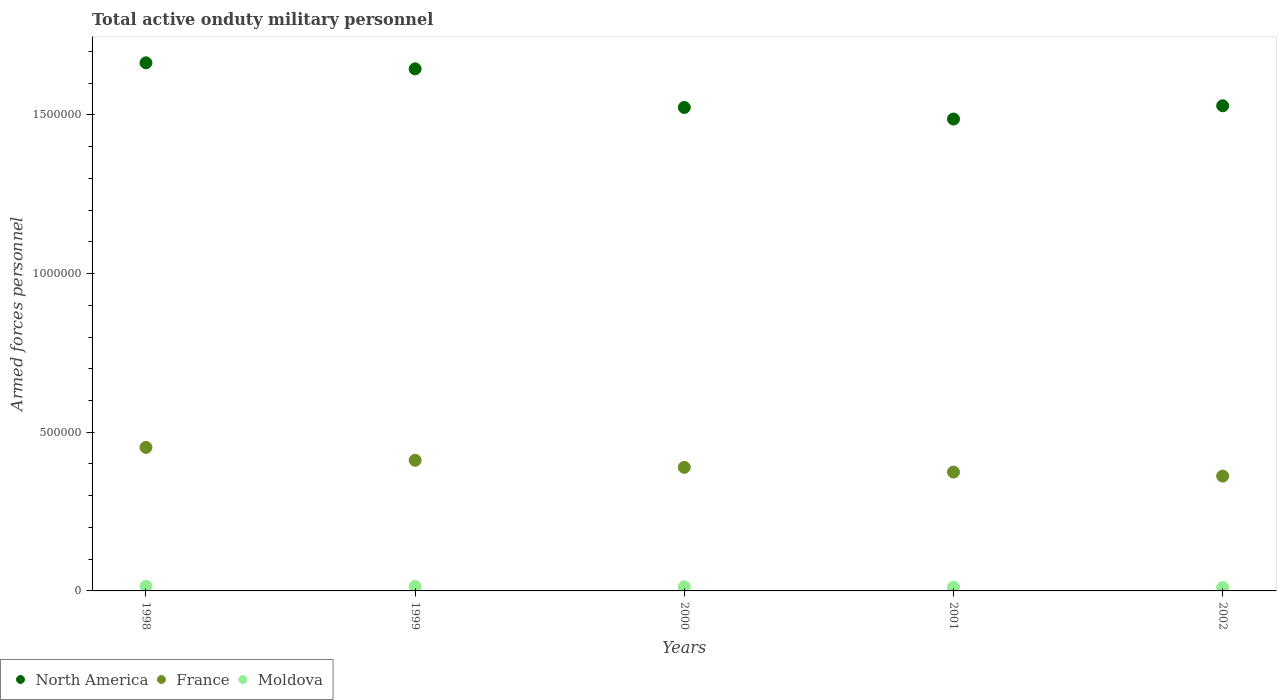What is the number of armed forces personnel in North America in 2002?
Offer a terse response. 1.53e+06. Across all years, what is the maximum number of armed forces personnel in Moldova?
Your answer should be compact. 1.44e+04. Across all years, what is the minimum number of armed forces personnel in France?
Give a very brief answer. 3.62e+05. In which year was the number of armed forces personnel in France maximum?
Your response must be concise. 1998. What is the total number of armed forces personnel in North America in the graph?
Offer a very short reply. 7.85e+06. What is the difference between the number of armed forces personnel in Moldova in 1999 and that in 2002?
Your response must be concise. 3450. What is the difference between the number of armed forces personnel in North America in 1999 and the number of armed forces personnel in Moldova in 2001?
Offer a terse response. 1.63e+06. What is the average number of armed forces personnel in Moldova per year?
Ensure brevity in your answer.  1.27e+04. In the year 1998, what is the difference between the number of armed forces personnel in North America and number of armed forces personnel in Moldova?
Give a very brief answer. 1.65e+06. In how many years, is the number of armed forces personnel in North America greater than 1500000?
Your response must be concise. 4. What is the ratio of the number of armed forces personnel in North America in 1998 to that in 1999?
Provide a succinct answer. 1.01. Is the number of armed forces personnel in North America in 1999 less than that in 2001?
Offer a very short reply. No. Is the difference between the number of armed forces personnel in North America in 1998 and 2001 greater than the difference between the number of armed forces personnel in Moldova in 1998 and 2001?
Provide a succinct answer. Yes. What is the difference between the highest and the second highest number of armed forces personnel in North America?
Provide a short and direct response. 1.90e+04. What is the difference between the highest and the lowest number of armed forces personnel in North America?
Your answer should be very brief. 1.77e+05. In how many years, is the number of armed forces personnel in Moldova greater than the average number of armed forces personnel in Moldova taken over all years?
Ensure brevity in your answer.  3. Does the number of armed forces personnel in Moldova monotonically increase over the years?
Make the answer very short. No. Is the number of armed forces personnel in Moldova strictly greater than the number of armed forces personnel in North America over the years?
Provide a succinct answer. No. How many years are there in the graph?
Make the answer very short. 5. What is the difference between two consecutive major ticks on the Y-axis?
Provide a short and direct response. 5.00e+05. Are the values on the major ticks of Y-axis written in scientific E-notation?
Offer a very short reply. No. Does the graph contain any zero values?
Your answer should be very brief. No. Where does the legend appear in the graph?
Offer a terse response. Bottom left. How are the legend labels stacked?
Your answer should be compact. Horizontal. What is the title of the graph?
Offer a terse response. Total active onduty military personnel. Does "Mozambique" appear as one of the legend labels in the graph?
Offer a terse response. No. What is the label or title of the X-axis?
Ensure brevity in your answer.  Years. What is the label or title of the Y-axis?
Offer a very short reply. Armed forces personnel. What is the Armed forces personnel in North America in 1998?
Provide a short and direct response. 1.66e+06. What is the Armed forces personnel in France in 1998?
Your answer should be compact. 4.52e+05. What is the Armed forces personnel of Moldova in 1998?
Offer a terse response. 1.44e+04. What is the Armed forces personnel of North America in 1999?
Your answer should be very brief. 1.64e+06. What is the Armed forces personnel in France in 1999?
Make the answer very short. 4.12e+05. What is the Armed forces personnel in Moldova in 1999?
Offer a very short reply. 1.40e+04. What is the Armed forces personnel in North America in 2000?
Offer a very short reply. 1.52e+06. What is the Armed forces personnel in France in 2000?
Ensure brevity in your answer.  3.89e+05. What is the Armed forces personnel in Moldova in 2000?
Your answer should be compact. 1.29e+04. What is the Armed forces personnel in North America in 2001?
Provide a succinct answer. 1.49e+06. What is the Armed forces personnel in France in 2001?
Your answer should be compact. 3.74e+05. What is the Armed forces personnel in Moldova in 2001?
Keep it short and to the point. 1.16e+04. What is the Armed forces personnel in North America in 2002?
Keep it short and to the point. 1.53e+06. What is the Armed forces personnel of France in 2002?
Provide a succinct answer. 3.62e+05. What is the Armed forces personnel in Moldova in 2002?
Make the answer very short. 1.06e+04. Across all years, what is the maximum Armed forces personnel in North America?
Make the answer very short. 1.66e+06. Across all years, what is the maximum Armed forces personnel in France?
Your answer should be compact. 4.52e+05. Across all years, what is the maximum Armed forces personnel of Moldova?
Give a very brief answer. 1.44e+04. Across all years, what is the minimum Armed forces personnel of North America?
Offer a very short reply. 1.49e+06. Across all years, what is the minimum Armed forces personnel in France?
Provide a short and direct response. 3.62e+05. Across all years, what is the minimum Armed forces personnel of Moldova?
Provide a succinct answer. 1.06e+04. What is the total Armed forces personnel of North America in the graph?
Provide a short and direct response. 7.85e+06. What is the total Armed forces personnel of France in the graph?
Provide a short and direct response. 1.99e+06. What is the total Armed forces personnel of Moldova in the graph?
Offer a terse response. 6.36e+04. What is the difference between the Armed forces personnel in North America in 1998 and that in 1999?
Keep it short and to the point. 1.90e+04. What is the difference between the Armed forces personnel of France in 1998 and that in 1999?
Your answer should be very brief. 4.06e+04. What is the difference between the Armed forces personnel in North America in 1998 and that in 2000?
Ensure brevity in your answer.  1.41e+05. What is the difference between the Armed forces personnel of France in 1998 and that in 2000?
Provide a succinct answer. 6.28e+04. What is the difference between the Armed forces personnel in Moldova in 1998 and that in 2000?
Your answer should be very brief. 1550. What is the difference between the Armed forces personnel in North America in 1998 and that in 2001?
Offer a very short reply. 1.77e+05. What is the difference between the Armed forces personnel in France in 1998 and that in 2001?
Offer a terse response. 7.78e+04. What is the difference between the Armed forces personnel of Moldova in 1998 and that in 2001?
Provide a succinct answer. 2850. What is the difference between the Armed forces personnel in North America in 1998 and that in 2002?
Ensure brevity in your answer.  1.35e+05. What is the difference between the Armed forces personnel in France in 1998 and that in 2002?
Make the answer very short. 9.04e+04. What is the difference between the Armed forces personnel of Moldova in 1998 and that in 2002?
Ensure brevity in your answer.  3850. What is the difference between the Armed forces personnel in North America in 1999 and that in 2000?
Your response must be concise. 1.22e+05. What is the difference between the Armed forces personnel of France in 1999 and that in 2000?
Keep it short and to the point. 2.22e+04. What is the difference between the Armed forces personnel of Moldova in 1999 and that in 2000?
Offer a very short reply. 1150. What is the difference between the Armed forces personnel of North America in 1999 and that in 2001?
Make the answer very short. 1.58e+05. What is the difference between the Armed forces personnel of France in 1999 and that in 2001?
Offer a very short reply. 3.72e+04. What is the difference between the Armed forces personnel in Moldova in 1999 and that in 2001?
Provide a short and direct response. 2450. What is the difference between the Armed forces personnel in North America in 1999 and that in 2002?
Your answer should be very brief. 1.16e+05. What is the difference between the Armed forces personnel in France in 1999 and that in 2002?
Give a very brief answer. 4.98e+04. What is the difference between the Armed forces personnel of Moldova in 1999 and that in 2002?
Offer a very short reply. 3450. What is the difference between the Armed forces personnel of North America in 2000 and that in 2001?
Provide a short and direct response. 3.65e+04. What is the difference between the Armed forces personnel of France in 2000 and that in 2001?
Provide a short and direct response. 1.50e+04. What is the difference between the Armed forces personnel of Moldova in 2000 and that in 2001?
Provide a short and direct response. 1300. What is the difference between the Armed forces personnel in North America in 2000 and that in 2002?
Give a very brief answer. -5300. What is the difference between the Armed forces personnel of France in 2000 and that in 2002?
Provide a succinct answer. 2.76e+04. What is the difference between the Armed forces personnel in Moldova in 2000 and that in 2002?
Offer a very short reply. 2300. What is the difference between the Armed forces personnel in North America in 2001 and that in 2002?
Ensure brevity in your answer.  -4.18e+04. What is the difference between the Armed forces personnel of France in 2001 and that in 2002?
Offer a terse response. 1.26e+04. What is the difference between the Armed forces personnel of Moldova in 2001 and that in 2002?
Make the answer very short. 1000. What is the difference between the Armed forces personnel of North America in 1998 and the Armed forces personnel of France in 1999?
Keep it short and to the point. 1.25e+06. What is the difference between the Armed forces personnel of North America in 1998 and the Armed forces personnel of Moldova in 1999?
Provide a short and direct response. 1.65e+06. What is the difference between the Armed forces personnel in France in 1998 and the Armed forces personnel in Moldova in 1999?
Keep it short and to the point. 4.38e+05. What is the difference between the Armed forces personnel of North America in 1998 and the Armed forces personnel of France in 2000?
Your answer should be compact. 1.27e+06. What is the difference between the Armed forces personnel of North America in 1998 and the Armed forces personnel of Moldova in 2000?
Provide a succinct answer. 1.65e+06. What is the difference between the Armed forces personnel in France in 1998 and the Armed forces personnel in Moldova in 2000?
Offer a very short reply. 4.39e+05. What is the difference between the Armed forces personnel of North America in 1998 and the Armed forces personnel of France in 2001?
Keep it short and to the point. 1.29e+06. What is the difference between the Armed forces personnel of North America in 1998 and the Armed forces personnel of Moldova in 2001?
Your answer should be very brief. 1.65e+06. What is the difference between the Armed forces personnel of France in 1998 and the Armed forces personnel of Moldova in 2001?
Keep it short and to the point. 4.41e+05. What is the difference between the Armed forces personnel in North America in 1998 and the Armed forces personnel in France in 2002?
Your answer should be compact. 1.30e+06. What is the difference between the Armed forces personnel in North America in 1998 and the Armed forces personnel in Moldova in 2002?
Give a very brief answer. 1.65e+06. What is the difference between the Armed forces personnel in France in 1998 and the Armed forces personnel in Moldova in 2002?
Your response must be concise. 4.42e+05. What is the difference between the Armed forces personnel in North America in 1999 and the Armed forces personnel in France in 2000?
Provide a succinct answer. 1.26e+06. What is the difference between the Armed forces personnel in North America in 1999 and the Armed forces personnel in Moldova in 2000?
Make the answer very short. 1.63e+06. What is the difference between the Armed forces personnel of France in 1999 and the Armed forces personnel of Moldova in 2000?
Offer a terse response. 3.99e+05. What is the difference between the Armed forces personnel in North America in 1999 and the Armed forces personnel in France in 2001?
Ensure brevity in your answer.  1.27e+06. What is the difference between the Armed forces personnel of North America in 1999 and the Armed forces personnel of Moldova in 2001?
Your answer should be compact. 1.63e+06. What is the difference between the Armed forces personnel in North America in 1999 and the Armed forces personnel in France in 2002?
Provide a short and direct response. 1.28e+06. What is the difference between the Armed forces personnel of North America in 1999 and the Armed forces personnel of Moldova in 2002?
Your answer should be very brief. 1.63e+06. What is the difference between the Armed forces personnel in France in 1999 and the Armed forces personnel in Moldova in 2002?
Your answer should be very brief. 4.01e+05. What is the difference between the Armed forces personnel of North America in 2000 and the Armed forces personnel of France in 2001?
Your response must be concise. 1.15e+06. What is the difference between the Armed forces personnel in North America in 2000 and the Armed forces personnel in Moldova in 2001?
Make the answer very short. 1.51e+06. What is the difference between the Armed forces personnel in France in 2000 and the Armed forces personnel in Moldova in 2001?
Ensure brevity in your answer.  3.78e+05. What is the difference between the Armed forces personnel of North America in 2000 and the Armed forces personnel of France in 2002?
Provide a short and direct response. 1.16e+06. What is the difference between the Armed forces personnel of North America in 2000 and the Armed forces personnel of Moldova in 2002?
Make the answer very short. 1.51e+06. What is the difference between the Armed forces personnel of France in 2000 and the Armed forces personnel of Moldova in 2002?
Keep it short and to the point. 3.79e+05. What is the difference between the Armed forces personnel in North America in 2001 and the Armed forces personnel in France in 2002?
Offer a terse response. 1.12e+06. What is the difference between the Armed forces personnel in North America in 2001 and the Armed forces personnel in Moldova in 2002?
Provide a short and direct response. 1.48e+06. What is the difference between the Armed forces personnel of France in 2001 and the Armed forces personnel of Moldova in 2002?
Your response must be concise. 3.64e+05. What is the average Armed forces personnel in North America per year?
Ensure brevity in your answer.  1.57e+06. What is the average Armed forces personnel in France per year?
Keep it short and to the point. 3.98e+05. What is the average Armed forces personnel of Moldova per year?
Make the answer very short. 1.27e+04. In the year 1998, what is the difference between the Armed forces personnel in North America and Armed forces personnel in France?
Make the answer very short. 1.21e+06. In the year 1998, what is the difference between the Armed forces personnel in North America and Armed forces personnel in Moldova?
Give a very brief answer. 1.65e+06. In the year 1998, what is the difference between the Armed forces personnel of France and Armed forces personnel of Moldova?
Provide a short and direct response. 4.38e+05. In the year 1999, what is the difference between the Armed forces personnel in North America and Armed forces personnel in France?
Offer a terse response. 1.23e+06. In the year 1999, what is the difference between the Armed forces personnel in North America and Armed forces personnel in Moldova?
Ensure brevity in your answer.  1.63e+06. In the year 1999, what is the difference between the Armed forces personnel of France and Armed forces personnel of Moldova?
Offer a terse response. 3.98e+05. In the year 2000, what is the difference between the Armed forces personnel in North America and Armed forces personnel in France?
Provide a succinct answer. 1.13e+06. In the year 2000, what is the difference between the Armed forces personnel of North America and Armed forces personnel of Moldova?
Offer a terse response. 1.51e+06. In the year 2000, what is the difference between the Armed forces personnel of France and Armed forces personnel of Moldova?
Your answer should be very brief. 3.76e+05. In the year 2001, what is the difference between the Armed forces personnel in North America and Armed forces personnel in France?
Give a very brief answer. 1.11e+06. In the year 2001, what is the difference between the Armed forces personnel of North America and Armed forces personnel of Moldova?
Ensure brevity in your answer.  1.48e+06. In the year 2001, what is the difference between the Armed forces personnel in France and Armed forces personnel in Moldova?
Your answer should be very brief. 3.63e+05. In the year 2002, what is the difference between the Armed forces personnel of North America and Armed forces personnel of France?
Provide a succinct answer. 1.17e+06. In the year 2002, what is the difference between the Armed forces personnel in North America and Armed forces personnel in Moldova?
Your answer should be very brief. 1.52e+06. In the year 2002, what is the difference between the Armed forces personnel in France and Armed forces personnel in Moldova?
Keep it short and to the point. 3.51e+05. What is the ratio of the Armed forces personnel of North America in 1998 to that in 1999?
Provide a short and direct response. 1.01. What is the ratio of the Armed forces personnel in France in 1998 to that in 1999?
Provide a succinct answer. 1.1. What is the ratio of the Armed forces personnel in Moldova in 1998 to that in 1999?
Make the answer very short. 1.03. What is the ratio of the Armed forces personnel of North America in 1998 to that in 2000?
Provide a short and direct response. 1.09. What is the ratio of the Armed forces personnel in France in 1998 to that in 2000?
Provide a succinct answer. 1.16. What is the ratio of the Armed forces personnel of Moldova in 1998 to that in 2000?
Offer a terse response. 1.12. What is the ratio of the Armed forces personnel in North America in 1998 to that in 2001?
Give a very brief answer. 1.12. What is the ratio of the Armed forces personnel of France in 1998 to that in 2001?
Ensure brevity in your answer.  1.21. What is the ratio of the Armed forces personnel of Moldova in 1998 to that in 2001?
Ensure brevity in your answer.  1.25. What is the ratio of the Armed forces personnel in North America in 1998 to that in 2002?
Provide a succinct answer. 1.09. What is the ratio of the Armed forces personnel of France in 1998 to that in 2002?
Keep it short and to the point. 1.25. What is the ratio of the Armed forces personnel of Moldova in 1998 to that in 2002?
Your answer should be very brief. 1.36. What is the ratio of the Armed forces personnel in North America in 1999 to that in 2000?
Offer a very short reply. 1.08. What is the ratio of the Armed forces personnel of France in 1999 to that in 2000?
Ensure brevity in your answer.  1.06. What is the ratio of the Armed forces personnel in Moldova in 1999 to that in 2000?
Provide a short and direct response. 1.09. What is the ratio of the Armed forces personnel in North America in 1999 to that in 2001?
Offer a very short reply. 1.11. What is the ratio of the Armed forces personnel of France in 1999 to that in 2001?
Keep it short and to the point. 1.1. What is the ratio of the Armed forces personnel in Moldova in 1999 to that in 2001?
Make the answer very short. 1.21. What is the ratio of the Armed forces personnel of North America in 1999 to that in 2002?
Provide a short and direct response. 1.08. What is the ratio of the Armed forces personnel of France in 1999 to that in 2002?
Give a very brief answer. 1.14. What is the ratio of the Armed forces personnel in Moldova in 1999 to that in 2002?
Offer a terse response. 1.33. What is the ratio of the Armed forces personnel in North America in 2000 to that in 2001?
Ensure brevity in your answer.  1.02. What is the ratio of the Armed forces personnel of France in 2000 to that in 2001?
Offer a very short reply. 1.04. What is the ratio of the Armed forces personnel of Moldova in 2000 to that in 2001?
Ensure brevity in your answer.  1.11. What is the ratio of the Armed forces personnel in France in 2000 to that in 2002?
Your answer should be compact. 1.08. What is the ratio of the Armed forces personnel of Moldova in 2000 to that in 2002?
Give a very brief answer. 1.22. What is the ratio of the Armed forces personnel in North America in 2001 to that in 2002?
Keep it short and to the point. 0.97. What is the ratio of the Armed forces personnel of France in 2001 to that in 2002?
Offer a terse response. 1.03. What is the ratio of the Armed forces personnel in Moldova in 2001 to that in 2002?
Keep it short and to the point. 1.09. What is the difference between the highest and the second highest Armed forces personnel of North America?
Your response must be concise. 1.90e+04. What is the difference between the highest and the second highest Armed forces personnel of France?
Give a very brief answer. 4.06e+04. What is the difference between the highest and the lowest Armed forces personnel of North America?
Your response must be concise. 1.77e+05. What is the difference between the highest and the lowest Armed forces personnel of France?
Ensure brevity in your answer.  9.04e+04. What is the difference between the highest and the lowest Armed forces personnel in Moldova?
Provide a succinct answer. 3850. 